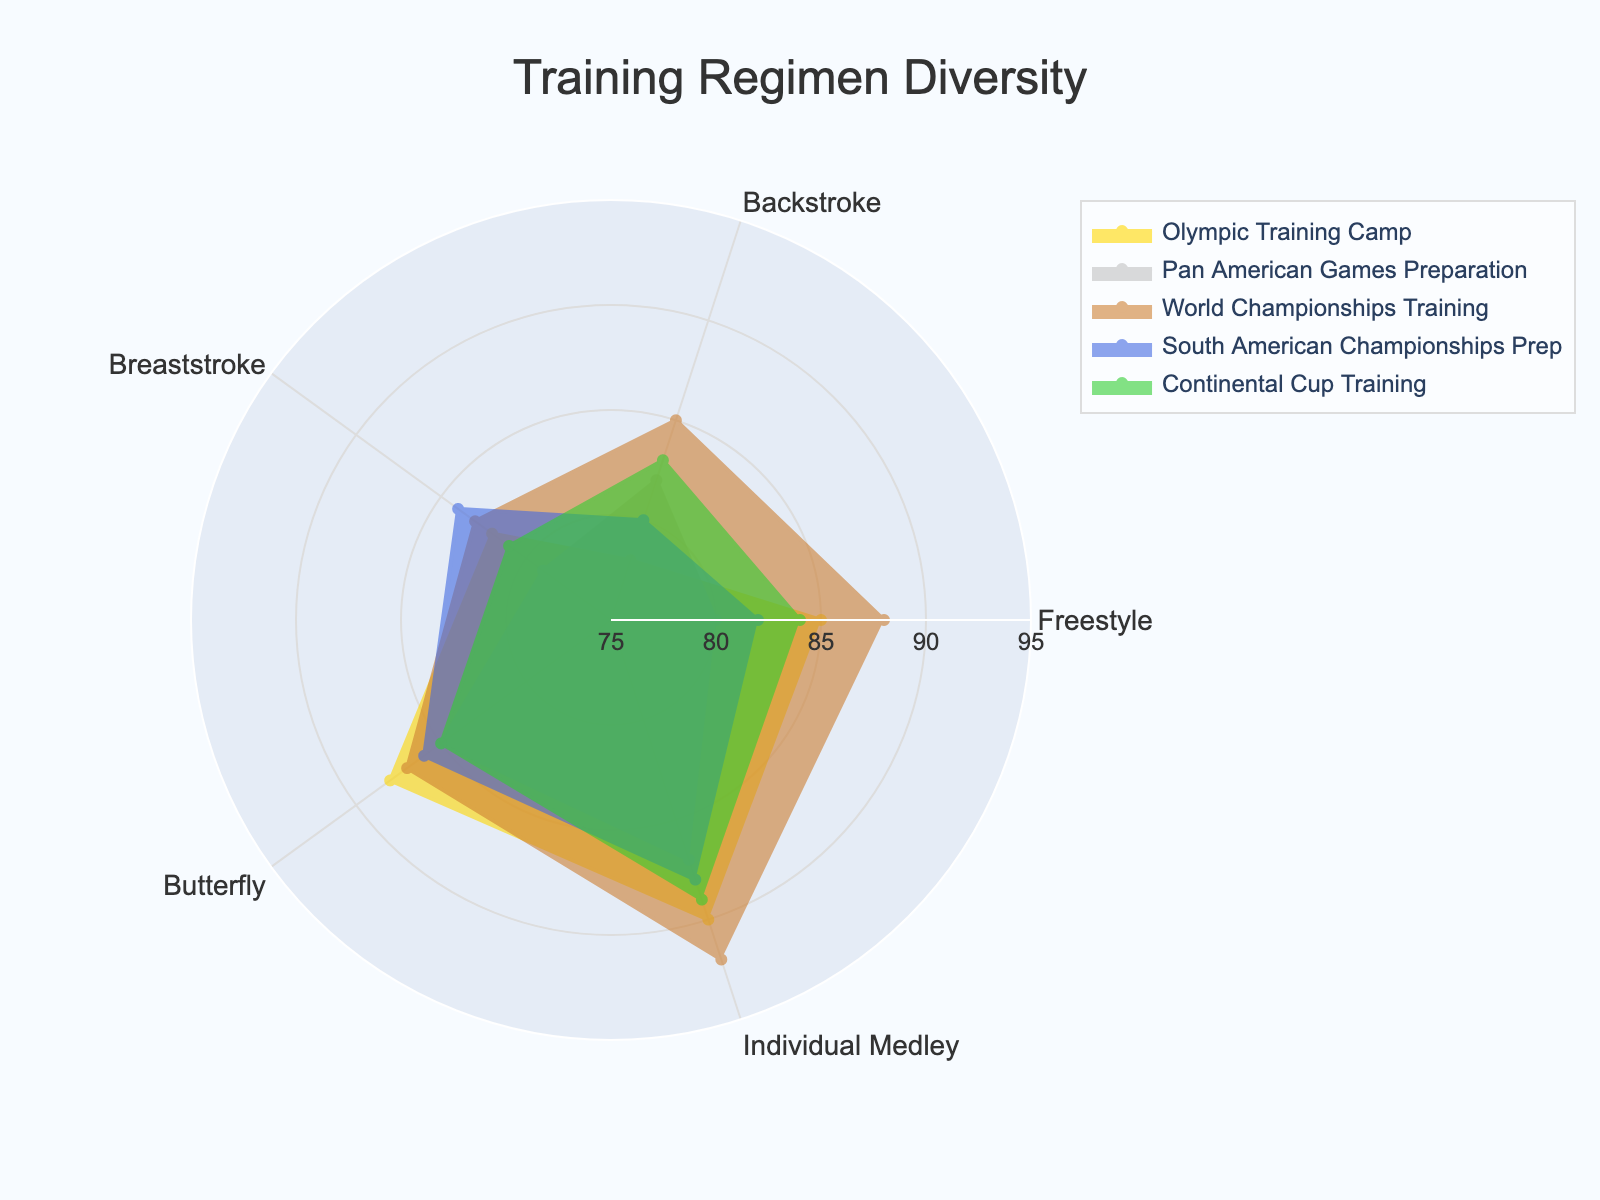What is the title of the radar chart? The title is displayed at the top of the radar chart, centered and in a larger font size, indicating the overall topic of the figure.
Answer: Training Regimen Diversity Which event has the highest value for Butterfly? By comparing the values for Butterfly for each event, the highest value is identified. Olympic Training Camp has the highest value for Butterfly (88) compared to the other events.
Answer: Olympic Training Camp What is the average value of Freestyle across all events? First, list the Freestyle values for all events: [85, 80, 88, 82, 84]. Then, sum these values: 85 + 80 + 88 + 82 + 84 = 419. Finally, divide by the number of events (5) to find the average: 419/5 = 83.8.
Answer: 83.8 Which stroke has the widest range of values across all events? Identify the maximum and minimum values for each stroke: Freestyle (max 88, min 80, range 8), Backstroke (max 85, min 78, range 7), Breaststroke (max 84, min 79, range 5), Butterfly (max 88, min 85, range 3), Individual Medley (max 92, min 87, range 5). Freestyle has the widest range of values (88 - 80 = 8).
Answer: Freestyle Which event shows the most balanced training regimen (smallest range between highest and lowest value)? Calculate the range for each event by subtracting the lowest value from the highest value within each event. Olympic Training Camp (90 - 78 = 12), Pan American Games Preparation (87 - 79 = 8), World Championships Training (92 - 83 = 9), South American Championships Prep (88 - 80 = 8), Continental Cup Training (89 - 81 = 8). Three events (Pan American Games Preparation, South American Championships Prep, Continental Cup Training) have the smallest range (8).
Answer: Pan American Games Preparation, South American Championships Prep, Continental Cup Training Which event has the second highest value for Individual Medley? Identify and rank the values for Individual Medley: [90, 87, 92, 88, 89]. The second highest value is 90. Checking the events, Olympic Training Camp corresponds to Individual Medley 90.
Answer: Olympic Training Camp For the event with the highest Backstroke value, what is the corresponding Freestyle value? Identify the event with the highest Backstroke value (World Championships Training, 85). The corresponding Freestyle value for this event is 88.
Answer: 88 How many events have at least one stroke with a value above 85? Check each event to see if at least one stroke has a value above 85: Olympic Training Camp (all but one), Pan American Games Preparation (one), World Championships Training (all but two), South American Championships Prep (two), Continental Cup Training (two). All five events have at least one stroke above 85.
Answer: 5 events 